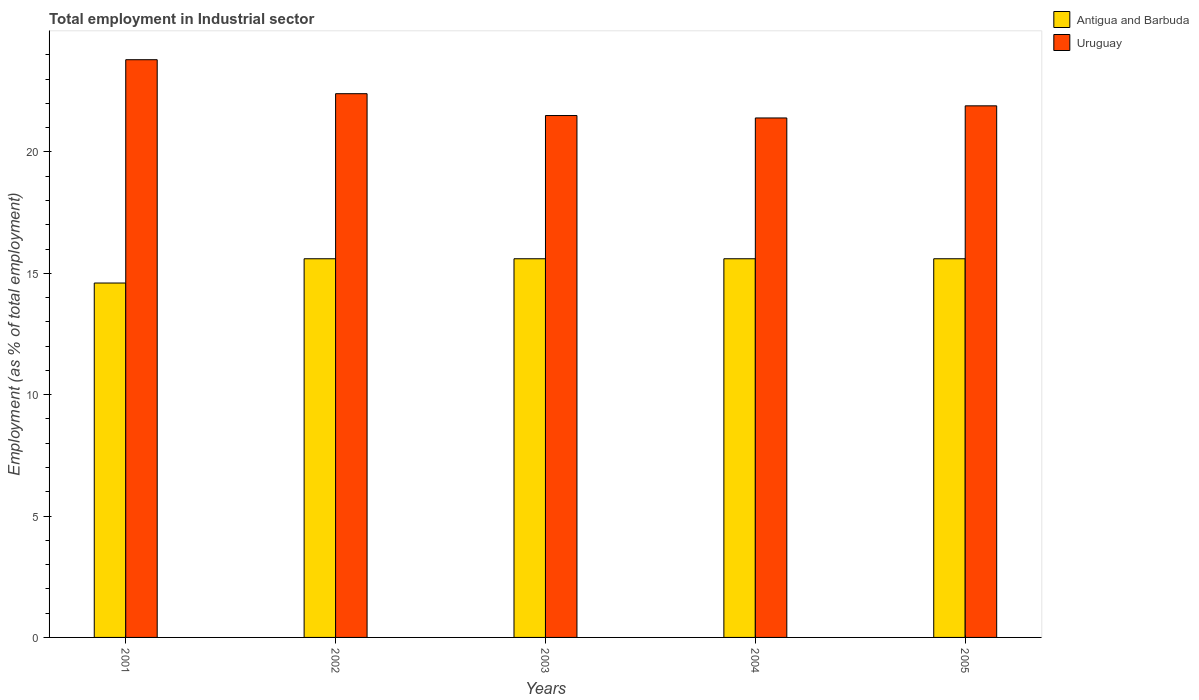How many groups of bars are there?
Keep it short and to the point. 5. Are the number of bars on each tick of the X-axis equal?
Offer a very short reply. Yes. What is the employment in industrial sector in Antigua and Barbuda in 2001?
Provide a succinct answer. 14.6. Across all years, what is the maximum employment in industrial sector in Antigua and Barbuda?
Make the answer very short. 15.6. Across all years, what is the minimum employment in industrial sector in Uruguay?
Give a very brief answer. 21.4. In which year was the employment in industrial sector in Antigua and Barbuda minimum?
Offer a very short reply. 2001. What is the total employment in industrial sector in Uruguay in the graph?
Your response must be concise. 111. What is the difference between the employment in industrial sector in Uruguay in 2001 and that in 2005?
Give a very brief answer. 1.9. What is the difference between the employment in industrial sector in Antigua and Barbuda in 2001 and the employment in industrial sector in Uruguay in 2002?
Ensure brevity in your answer.  -7.8. What is the average employment in industrial sector in Antigua and Barbuda per year?
Ensure brevity in your answer.  15.4. In the year 2004, what is the difference between the employment in industrial sector in Antigua and Barbuda and employment in industrial sector in Uruguay?
Your response must be concise. -5.8. In how many years, is the employment in industrial sector in Antigua and Barbuda greater than 9 %?
Provide a short and direct response. 5. Is the employment in industrial sector in Antigua and Barbuda in 2001 less than that in 2002?
Give a very brief answer. Yes. Is the difference between the employment in industrial sector in Antigua and Barbuda in 2004 and 2005 greater than the difference between the employment in industrial sector in Uruguay in 2004 and 2005?
Offer a terse response. Yes. In how many years, is the employment in industrial sector in Uruguay greater than the average employment in industrial sector in Uruguay taken over all years?
Ensure brevity in your answer.  2. What does the 1st bar from the left in 2004 represents?
Keep it short and to the point. Antigua and Barbuda. What does the 2nd bar from the right in 2004 represents?
Your answer should be very brief. Antigua and Barbuda. How many bars are there?
Your answer should be compact. 10. Are the values on the major ticks of Y-axis written in scientific E-notation?
Keep it short and to the point. No. Does the graph contain any zero values?
Offer a terse response. No. Does the graph contain grids?
Your answer should be compact. No. Where does the legend appear in the graph?
Give a very brief answer. Top right. How many legend labels are there?
Provide a succinct answer. 2. How are the legend labels stacked?
Offer a very short reply. Vertical. What is the title of the graph?
Offer a terse response. Total employment in Industrial sector. What is the label or title of the X-axis?
Provide a short and direct response. Years. What is the label or title of the Y-axis?
Ensure brevity in your answer.  Employment (as % of total employment). What is the Employment (as % of total employment) of Antigua and Barbuda in 2001?
Provide a succinct answer. 14.6. What is the Employment (as % of total employment) in Uruguay in 2001?
Make the answer very short. 23.8. What is the Employment (as % of total employment) in Antigua and Barbuda in 2002?
Your response must be concise. 15.6. What is the Employment (as % of total employment) of Uruguay in 2002?
Your answer should be compact. 22.4. What is the Employment (as % of total employment) of Antigua and Barbuda in 2003?
Ensure brevity in your answer.  15.6. What is the Employment (as % of total employment) in Uruguay in 2003?
Give a very brief answer. 21.5. What is the Employment (as % of total employment) in Antigua and Barbuda in 2004?
Offer a very short reply. 15.6. What is the Employment (as % of total employment) of Uruguay in 2004?
Provide a short and direct response. 21.4. What is the Employment (as % of total employment) of Antigua and Barbuda in 2005?
Your answer should be very brief. 15.6. What is the Employment (as % of total employment) of Uruguay in 2005?
Keep it short and to the point. 21.9. Across all years, what is the maximum Employment (as % of total employment) of Antigua and Barbuda?
Your answer should be compact. 15.6. Across all years, what is the maximum Employment (as % of total employment) of Uruguay?
Your answer should be very brief. 23.8. Across all years, what is the minimum Employment (as % of total employment) of Antigua and Barbuda?
Offer a very short reply. 14.6. Across all years, what is the minimum Employment (as % of total employment) in Uruguay?
Your response must be concise. 21.4. What is the total Employment (as % of total employment) of Uruguay in the graph?
Offer a terse response. 111. What is the difference between the Employment (as % of total employment) of Antigua and Barbuda in 2001 and that in 2002?
Make the answer very short. -1. What is the difference between the Employment (as % of total employment) in Uruguay in 2001 and that in 2002?
Keep it short and to the point. 1.4. What is the difference between the Employment (as % of total employment) in Antigua and Barbuda in 2001 and that in 2003?
Your response must be concise. -1. What is the difference between the Employment (as % of total employment) in Antigua and Barbuda in 2002 and that in 2003?
Offer a terse response. 0. What is the difference between the Employment (as % of total employment) in Antigua and Barbuda in 2002 and that in 2005?
Give a very brief answer. 0. What is the difference between the Employment (as % of total employment) in Antigua and Barbuda in 2003 and that in 2004?
Your answer should be very brief. 0. What is the difference between the Employment (as % of total employment) in Uruguay in 2003 and that in 2005?
Give a very brief answer. -0.4. What is the difference between the Employment (as % of total employment) of Antigua and Barbuda in 2004 and that in 2005?
Give a very brief answer. 0. What is the difference between the Employment (as % of total employment) of Uruguay in 2004 and that in 2005?
Your answer should be compact. -0.5. What is the difference between the Employment (as % of total employment) of Antigua and Barbuda in 2001 and the Employment (as % of total employment) of Uruguay in 2005?
Provide a succinct answer. -7.3. What is the difference between the Employment (as % of total employment) in Antigua and Barbuda in 2003 and the Employment (as % of total employment) in Uruguay in 2005?
Provide a short and direct response. -6.3. What is the difference between the Employment (as % of total employment) of Antigua and Barbuda in 2004 and the Employment (as % of total employment) of Uruguay in 2005?
Give a very brief answer. -6.3. In the year 2002, what is the difference between the Employment (as % of total employment) in Antigua and Barbuda and Employment (as % of total employment) in Uruguay?
Give a very brief answer. -6.8. In the year 2004, what is the difference between the Employment (as % of total employment) in Antigua and Barbuda and Employment (as % of total employment) in Uruguay?
Your response must be concise. -5.8. In the year 2005, what is the difference between the Employment (as % of total employment) in Antigua and Barbuda and Employment (as % of total employment) in Uruguay?
Your answer should be compact. -6.3. What is the ratio of the Employment (as % of total employment) in Antigua and Barbuda in 2001 to that in 2002?
Keep it short and to the point. 0.94. What is the ratio of the Employment (as % of total employment) of Antigua and Barbuda in 2001 to that in 2003?
Ensure brevity in your answer.  0.94. What is the ratio of the Employment (as % of total employment) of Uruguay in 2001 to that in 2003?
Your answer should be very brief. 1.11. What is the ratio of the Employment (as % of total employment) of Antigua and Barbuda in 2001 to that in 2004?
Give a very brief answer. 0.94. What is the ratio of the Employment (as % of total employment) in Uruguay in 2001 to that in 2004?
Give a very brief answer. 1.11. What is the ratio of the Employment (as % of total employment) of Antigua and Barbuda in 2001 to that in 2005?
Provide a short and direct response. 0.94. What is the ratio of the Employment (as % of total employment) in Uruguay in 2001 to that in 2005?
Keep it short and to the point. 1.09. What is the ratio of the Employment (as % of total employment) in Antigua and Barbuda in 2002 to that in 2003?
Offer a very short reply. 1. What is the ratio of the Employment (as % of total employment) in Uruguay in 2002 to that in 2003?
Offer a very short reply. 1.04. What is the ratio of the Employment (as % of total employment) in Antigua and Barbuda in 2002 to that in 2004?
Provide a succinct answer. 1. What is the ratio of the Employment (as % of total employment) in Uruguay in 2002 to that in 2004?
Your response must be concise. 1.05. What is the ratio of the Employment (as % of total employment) of Uruguay in 2002 to that in 2005?
Offer a very short reply. 1.02. What is the ratio of the Employment (as % of total employment) in Antigua and Barbuda in 2003 to that in 2004?
Provide a succinct answer. 1. What is the ratio of the Employment (as % of total employment) in Uruguay in 2003 to that in 2004?
Keep it short and to the point. 1. What is the ratio of the Employment (as % of total employment) in Uruguay in 2003 to that in 2005?
Keep it short and to the point. 0.98. What is the ratio of the Employment (as % of total employment) of Uruguay in 2004 to that in 2005?
Offer a terse response. 0.98. What is the difference between the highest and the second highest Employment (as % of total employment) of Antigua and Barbuda?
Make the answer very short. 0. What is the difference between the highest and the second highest Employment (as % of total employment) of Uruguay?
Provide a succinct answer. 1.4. What is the difference between the highest and the lowest Employment (as % of total employment) of Antigua and Barbuda?
Offer a terse response. 1. 